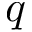Convert formula to latex. <formula><loc_0><loc_0><loc_500><loc_500>q</formula> 